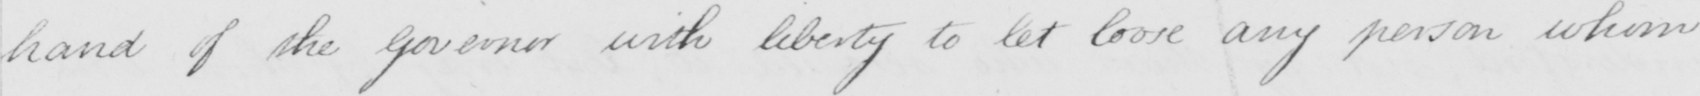Transcribe the text shown in this historical manuscript line. hand of the Governor with liberty to let loose any person whom 